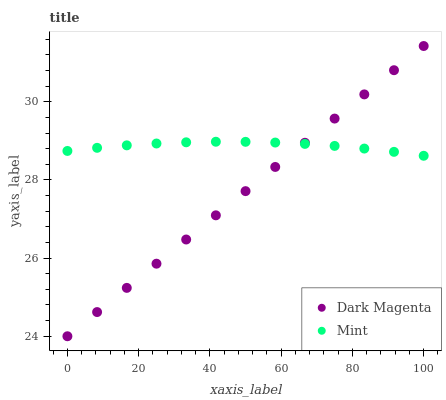Does Dark Magenta have the minimum area under the curve?
Answer yes or no. Yes. Does Mint have the maximum area under the curve?
Answer yes or no. Yes. Does Dark Magenta have the maximum area under the curve?
Answer yes or no. No. Is Dark Magenta the smoothest?
Answer yes or no. Yes. Is Mint the roughest?
Answer yes or no. Yes. Is Dark Magenta the roughest?
Answer yes or no. No. Does Dark Magenta have the lowest value?
Answer yes or no. Yes. Does Dark Magenta have the highest value?
Answer yes or no. Yes. Does Mint intersect Dark Magenta?
Answer yes or no. Yes. Is Mint less than Dark Magenta?
Answer yes or no. No. Is Mint greater than Dark Magenta?
Answer yes or no. No. 